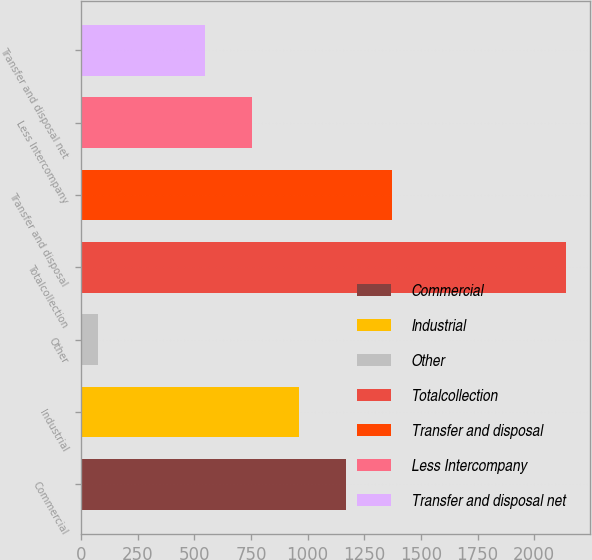Convert chart. <chart><loc_0><loc_0><loc_500><loc_500><bar_chart><fcel>Commercial<fcel>Industrial<fcel>Other<fcel>Totalcollection<fcel>Transfer and disposal<fcel>Less Intercompany<fcel>Transfer and disposal net<nl><fcel>1167.25<fcel>961<fcel>76.6<fcel>2139.1<fcel>1373.5<fcel>754.75<fcel>548.5<nl></chart> 